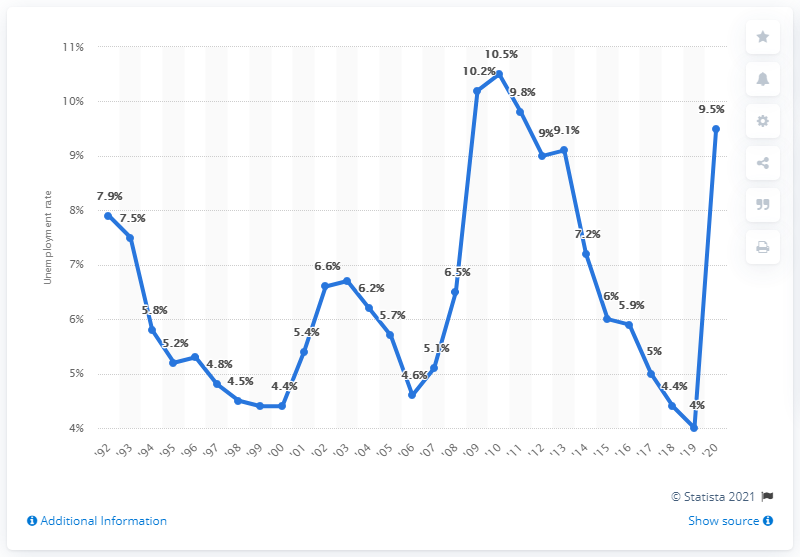Specify some key components in this picture. The unemployment rate in the state of Illinois was 10.5% in 2010. The unemployment rate in Illinois was 9.5% in 2020. 